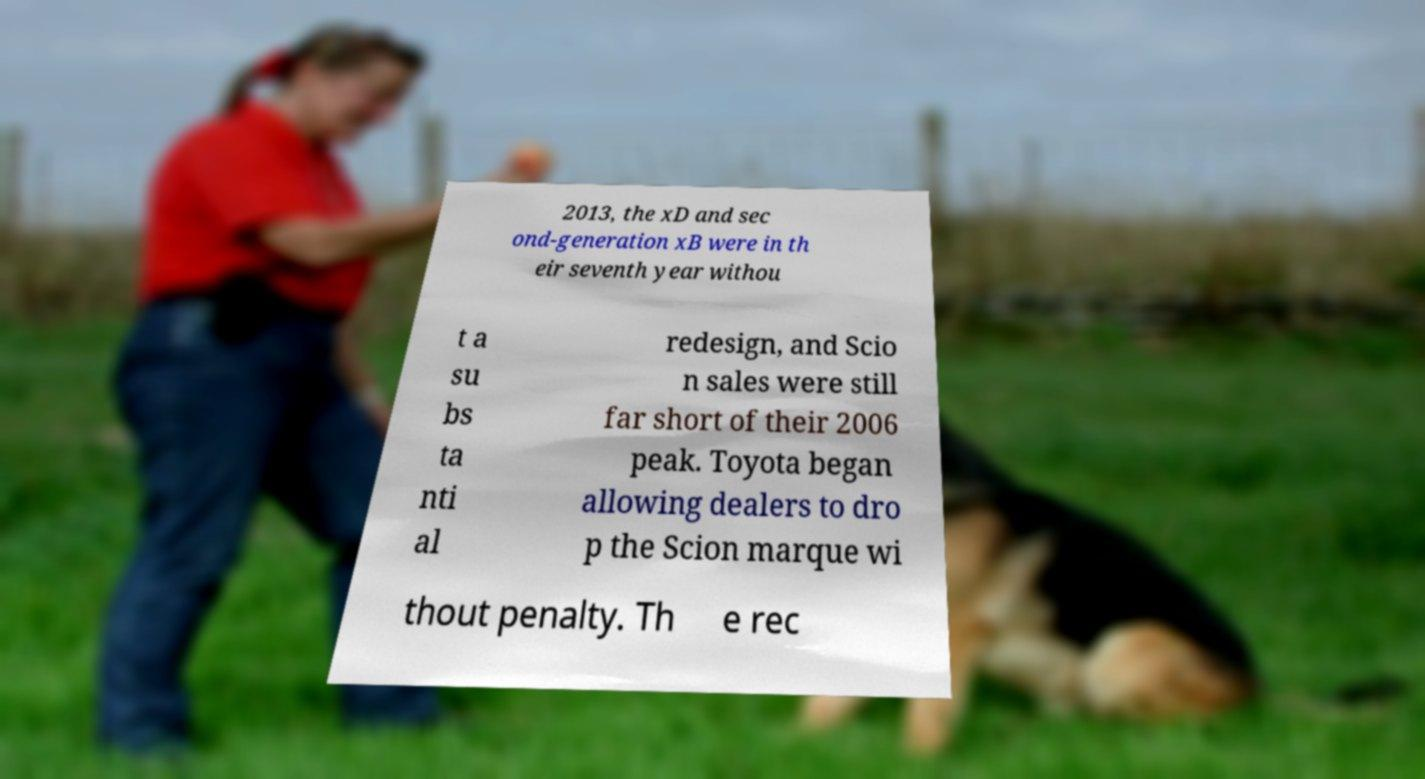What messages or text are displayed in this image? I need them in a readable, typed format. 2013, the xD and sec ond-generation xB were in th eir seventh year withou t a su bs ta nti al redesign, and Scio n sales were still far short of their 2006 peak. Toyota began allowing dealers to dro p the Scion marque wi thout penalty. Th e rec 